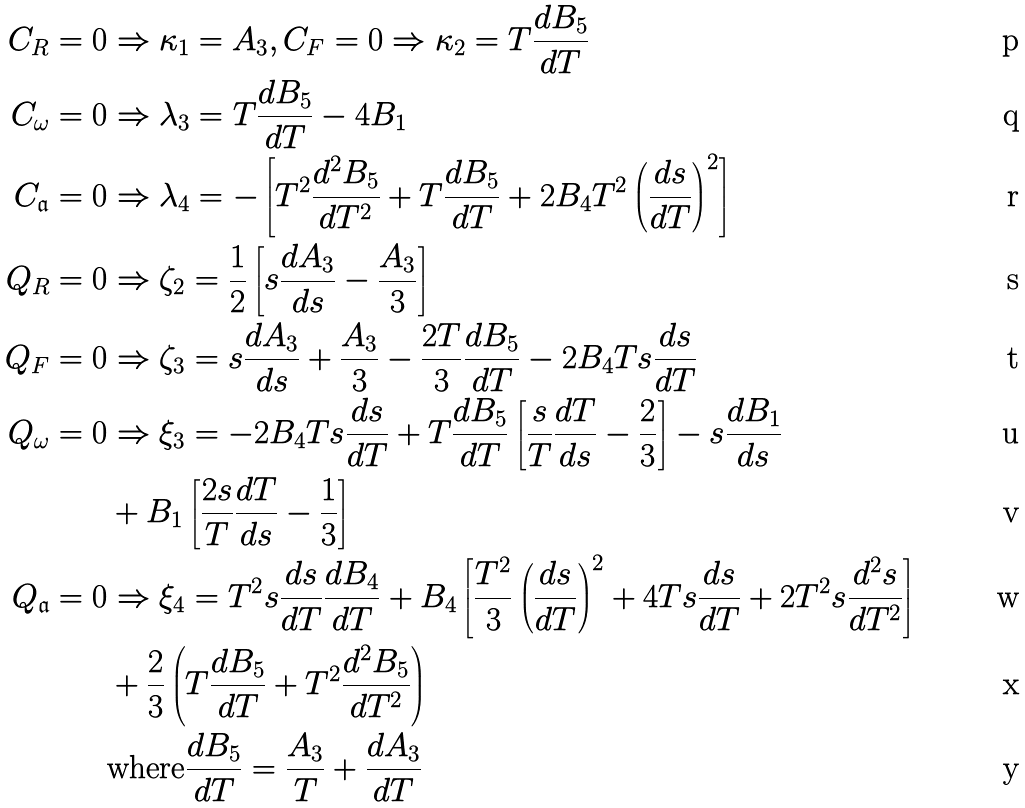<formula> <loc_0><loc_0><loc_500><loc_500>C _ { R } = 0 & \Rightarrow \kappa _ { 1 } = A _ { 3 } , C _ { F } = 0 \Rightarrow \kappa _ { 2 } = T \frac { d B _ { 5 } } { d T } \\ C _ { \omega } = 0 & \Rightarrow \lambda _ { 3 } = T \frac { d B _ { 5 } } { d T } - 4 B _ { 1 } \\ C _ { \mathfrak a } = 0 & \Rightarrow \lambda _ { 4 } = - \left [ T ^ { 2 } \frac { d ^ { 2 } B _ { 5 } } { d T ^ { 2 } } + T \frac { d B _ { 5 } } { d T } + 2 B _ { 4 } T ^ { 2 } \left ( \frac { d s } { d T } \right ) ^ { 2 } \right ] \\ Q _ { R } = 0 & \Rightarrow \zeta _ { 2 } = \frac { 1 } { 2 } \left [ s \frac { d A _ { 3 } } { d s } - \frac { A _ { 3 } } { 3 } \right ] \\ Q _ { F } = 0 & \Rightarrow \zeta _ { 3 } = s \frac { d A _ { 3 } } { d s } + \frac { A _ { 3 } } { 3 } - \frac { 2 T } { 3 } \frac { d B _ { 5 } } { d T } - 2 B _ { 4 } T s \frac { d s } { d T } \\ Q _ { \omega } = 0 & \Rightarrow \xi _ { 3 } = - 2 B _ { 4 } T s \frac { d s } { d T } + T \frac { d B _ { 5 } } { d T } \left [ \frac { s } { T } \frac { d T } { d s } - \frac { 2 } { 3 } \right ] - s \frac { d B _ { 1 } } { d s } \\ & + B _ { 1 } \left [ \frac { 2 s } { T } \frac { d T } { d s } - \frac { 1 } { 3 } \right ] \\ Q _ { \mathfrak a } = 0 & \Rightarrow \xi _ { 4 } = T ^ { 2 } s \frac { d s } { d T } \frac { d B _ { 4 } } { d T } + B _ { 4 } \left [ \frac { T ^ { 2 } } { 3 } \left ( \frac { d s } { d T } \right ) ^ { 2 } + 4 T s \frac { d s } { d T } + 2 T ^ { 2 } s \frac { d ^ { 2 } s } { d T ^ { 2 } } \right ] \\ & + \frac { 2 } { 3 } \left ( T \frac { d B _ { 5 } } { d T } + T ^ { 2 } \frac { d ^ { 2 } B _ { 5 } } { d T ^ { 2 } } \right ) \\ & \text {where} \frac { d B _ { 5 } } { d T } = \frac { A _ { 3 } } { T } + \frac { d A _ { 3 } } { d T }</formula> 